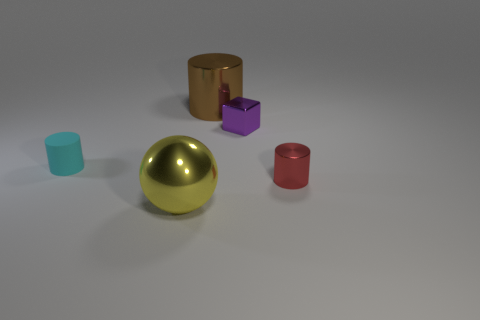Is there anything else that has the same material as the cyan cylinder?
Your response must be concise. No. What is the shape of the small object that is both left of the red cylinder and on the right side of the small matte object?
Offer a very short reply. Cube. How many yellow objects are large rubber spheres or big objects?
Your answer should be compact. 1. There is a purple cube that is behind the cyan cylinder; is it the same size as the object to the left of the big yellow metallic thing?
Provide a succinct answer. Yes. How many things are gray rubber objects or large yellow metallic things?
Offer a very short reply. 1. Are there any brown shiny objects of the same shape as the yellow thing?
Make the answer very short. No. Is the number of purple rubber cubes less than the number of tiny red metallic cylinders?
Give a very brief answer. Yes. Is the shape of the big brown object the same as the small cyan rubber thing?
Your response must be concise. Yes. How many things are small metallic blocks or cylinders that are to the right of the matte cylinder?
Your response must be concise. 3. What number of tiny purple cubes are there?
Keep it short and to the point. 1. 